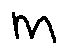Convert formula to latex. <formula><loc_0><loc_0><loc_500><loc_500>m</formula> 